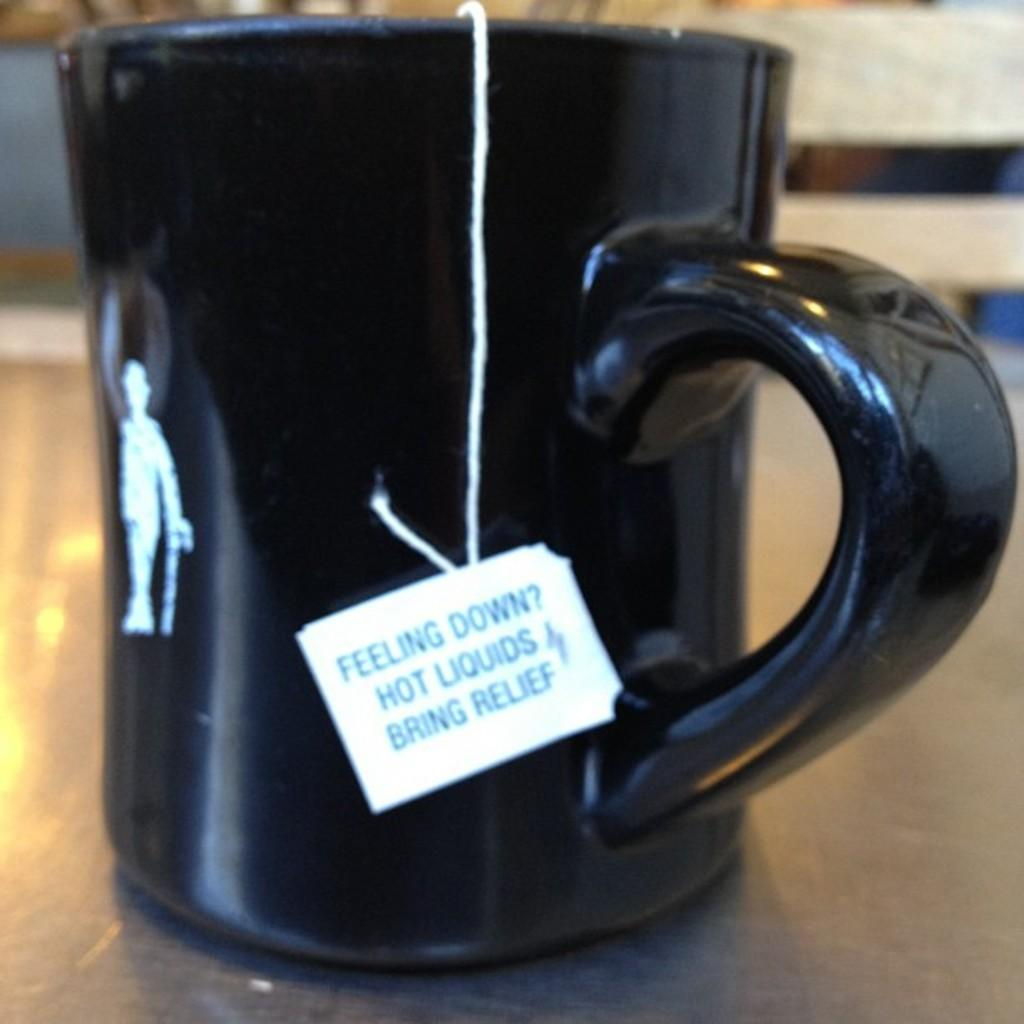Provide a one-sentence caption for the provided image. A black mug on a table with a teabag that says Feeling Down Hot Liquids Bring Relief. 